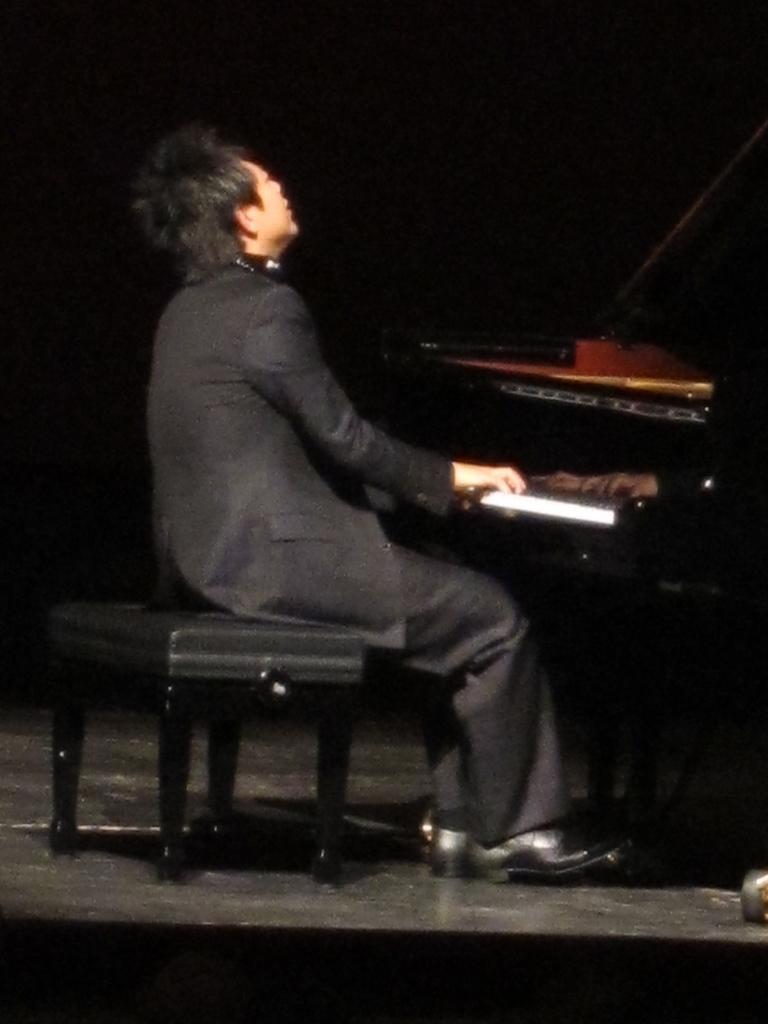How would you summarize this image in a sentence or two? In this image we can see a person sitting on the stool near the piano. 